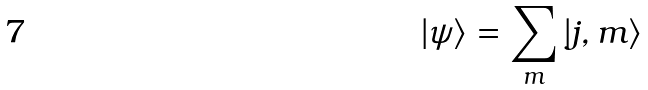<formula> <loc_0><loc_0><loc_500><loc_500>| \psi \rangle = \sum _ { m } | j , m \rangle</formula> 